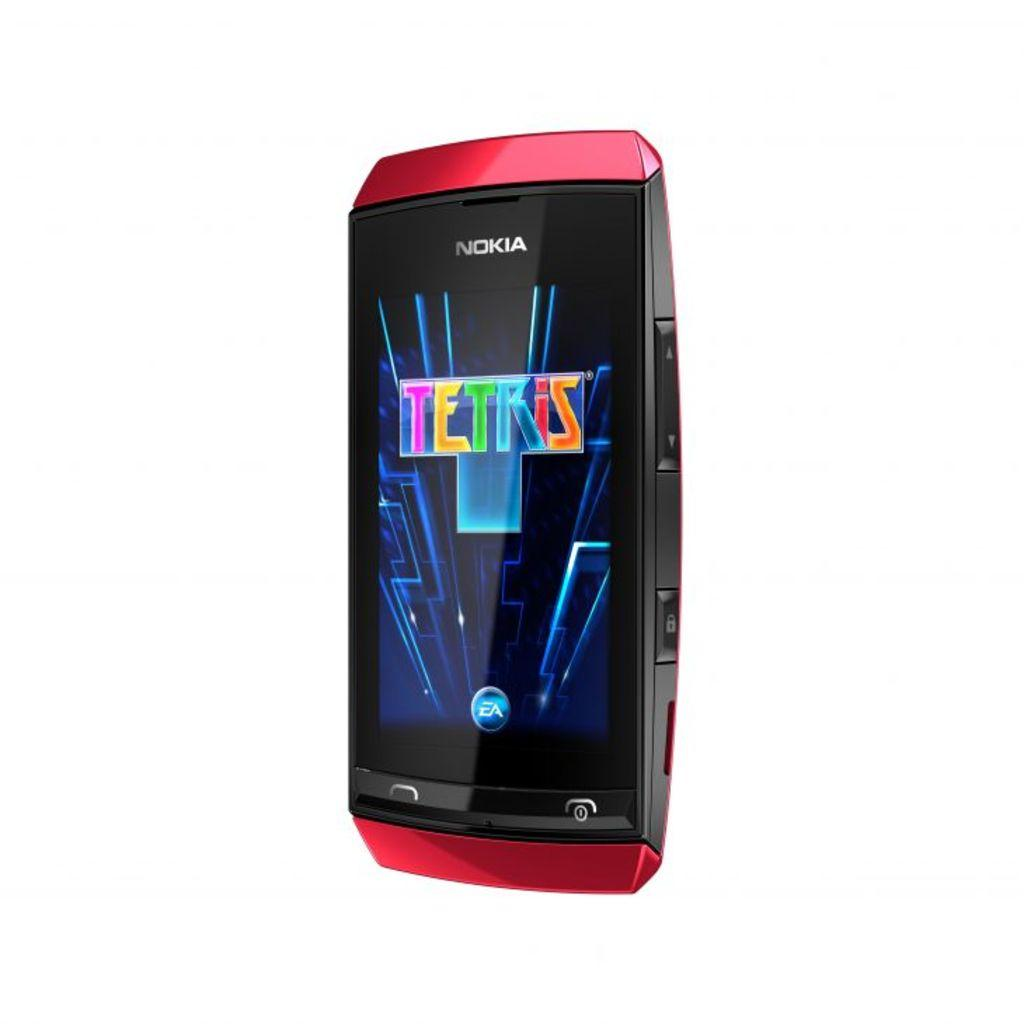Provide a one-sentence caption for the provided image. A red Nokia phone has a game on the screen called Tetris. 